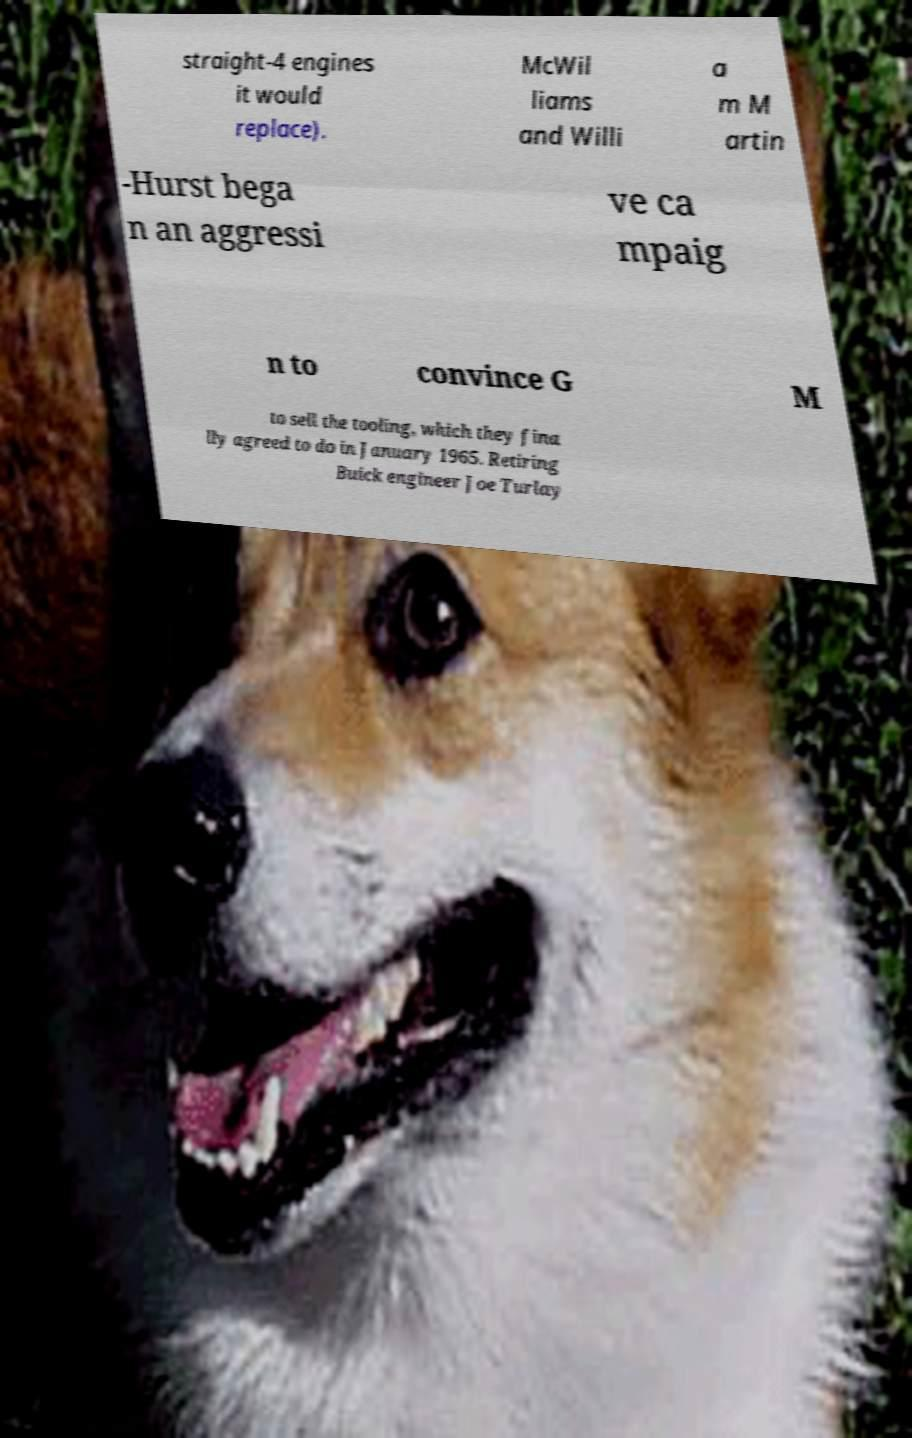Can you read and provide the text displayed in the image?This photo seems to have some interesting text. Can you extract and type it out for me? straight-4 engines it would replace). McWil liams and Willi a m M artin -Hurst bega n an aggressi ve ca mpaig n to convince G M to sell the tooling, which they fina lly agreed to do in January 1965. Retiring Buick engineer Joe Turlay 